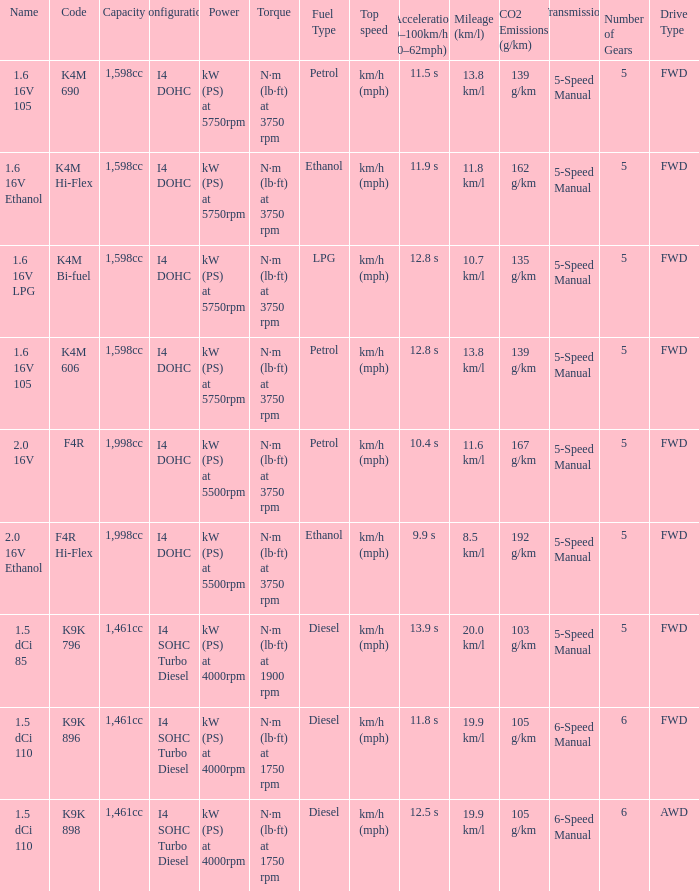What is the capacity of code f4r? 1,998cc. 